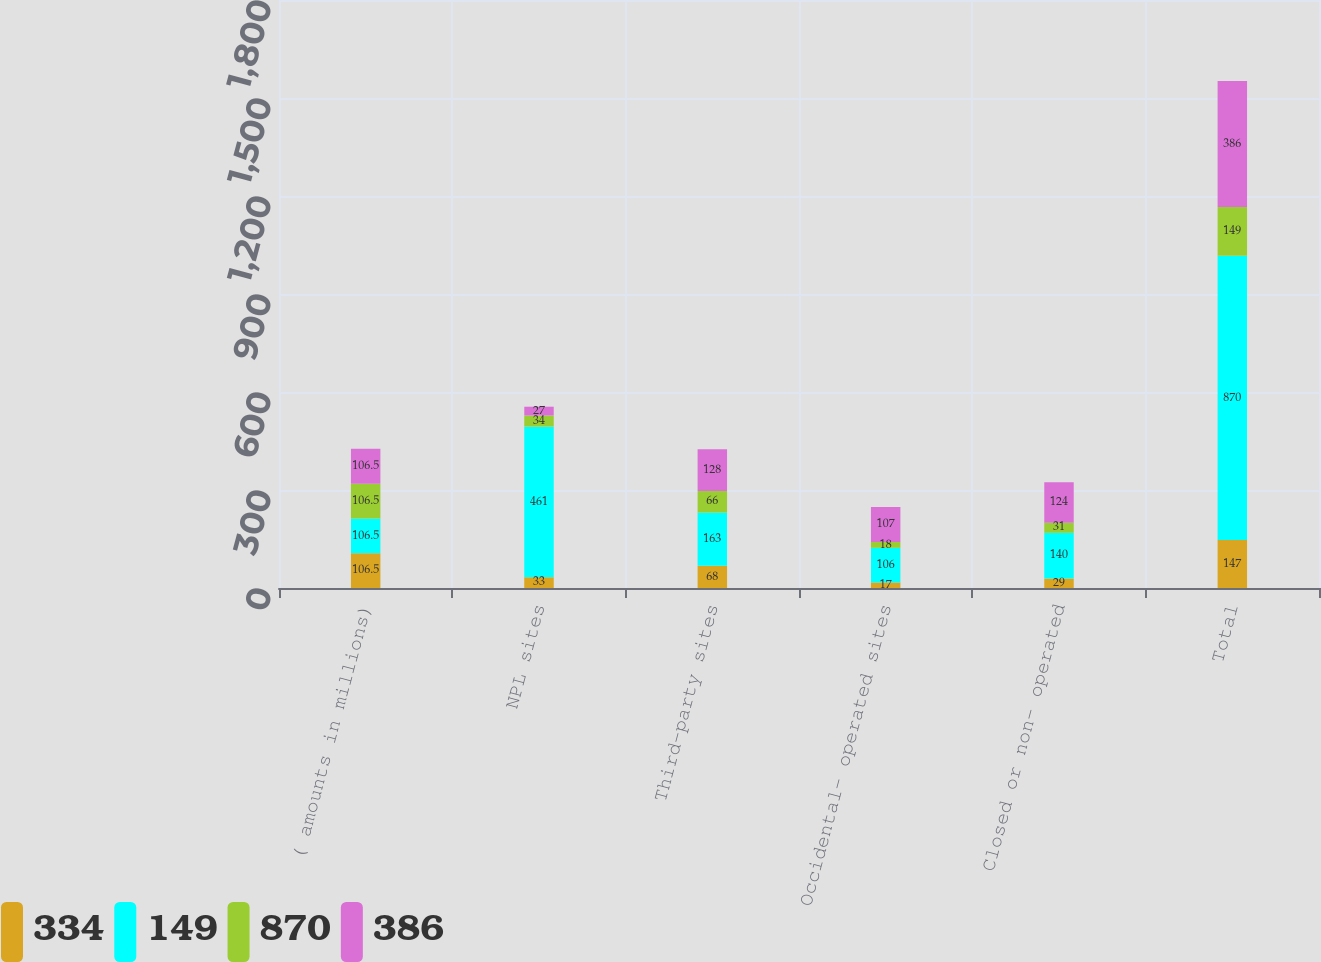<chart> <loc_0><loc_0><loc_500><loc_500><stacked_bar_chart><ecel><fcel>( amounts in millions)<fcel>NPL sites<fcel>Third-party sites<fcel>Occidental- operated sites<fcel>Closed or non- operated<fcel>Total<nl><fcel>334<fcel>106.5<fcel>33<fcel>68<fcel>17<fcel>29<fcel>147<nl><fcel>149<fcel>106.5<fcel>461<fcel>163<fcel>106<fcel>140<fcel>870<nl><fcel>870<fcel>106.5<fcel>34<fcel>66<fcel>18<fcel>31<fcel>149<nl><fcel>386<fcel>106.5<fcel>27<fcel>128<fcel>107<fcel>124<fcel>386<nl></chart> 